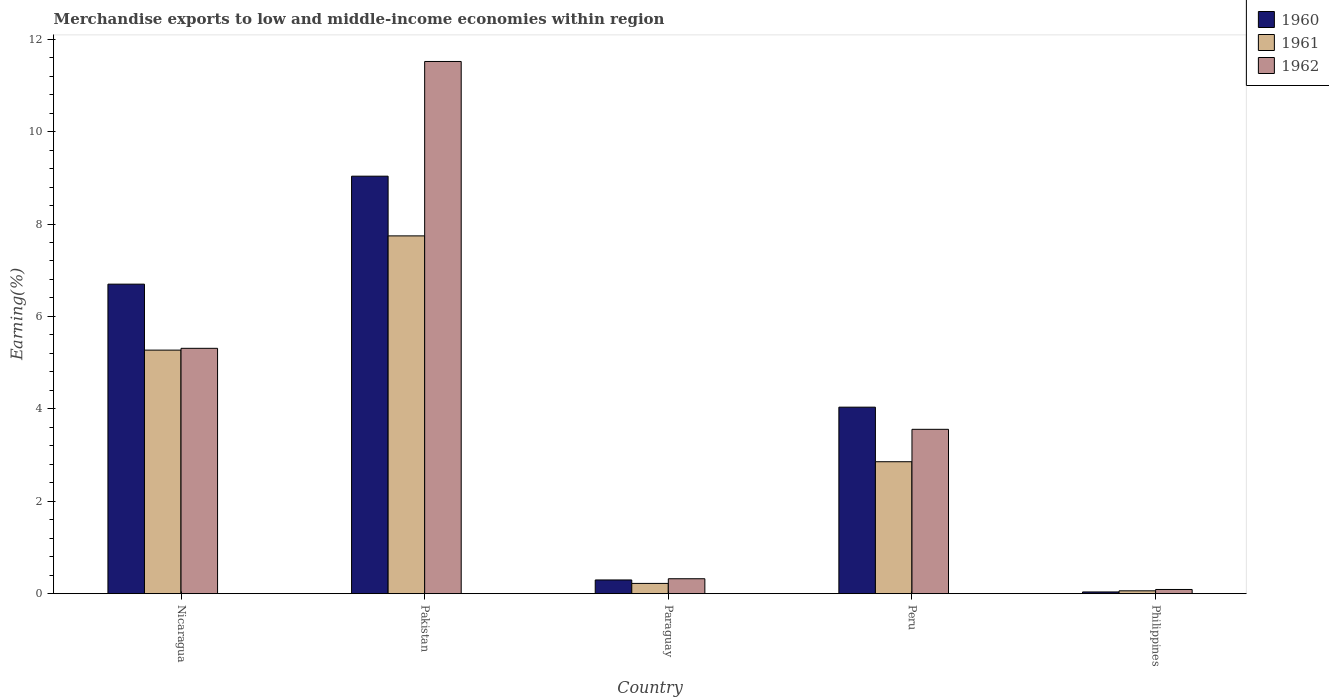Are the number of bars on each tick of the X-axis equal?
Give a very brief answer. Yes. How many bars are there on the 5th tick from the left?
Your answer should be very brief. 3. How many bars are there on the 1st tick from the right?
Ensure brevity in your answer.  3. What is the label of the 1st group of bars from the left?
Give a very brief answer. Nicaragua. What is the percentage of amount earned from merchandise exports in 1962 in Peru?
Give a very brief answer. 3.56. Across all countries, what is the maximum percentage of amount earned from merchandise exports in 1961?
Keep it short and to the point. 7.74. Across all countries, what is the minimum percentage of amount earned from merchandise exports in 1960?
Provide a short and direct response. 0.04. In which country was the percentage of amount earned from merchandise exports in 1961 maximum?
Provide a short and direct response. Pakistan. What is the total percentage of amount earned from merchandise exports in 1962 in the graph?
Provide a short and direct response. 20.8. What is the difference between the percentage of amount earned from merchandise exports in 1960 in Paraguay and that in Peru?
Ensure brevity in your answer.  -3.74. What is the difference between the percentage of amount earned from merchandise exports in 1960 in Pakistan and the percentage of amount earned from merchandise exports in 1962 in Peru?
Make the answer very short. 5.48. What is the average percentage of amount earned from merchandise exports in 1962 per country?
Give a very brief answer. 4.16. What is the difference between the percentage of amount earned from merchandise exports of/in 1962 and percentage of amount earned from merchandise exports of/in 1961 in Peru?
Your answer should be very brief. 0.7. What is the ratio of the percentage of amount earned from merchandise exports in 1962 in Paraguay to that in Peru?
Offer a very short reply. 0.09. What is the difference between the highest and the second highest percentage of amount earned from merchandise exports in 1960?
Offer a terse response. 5. What is the difference between the highest and the lowest percentage of amount earned from merchandise exports in 1961?
Make the answer very short. 7.68. What does the 2nd bar from the right in Philippines represents?
Keep it short and to the point. 1961. Is it the case that in every country, the sum of the percentage of amount earned from merchandise exports in 1962 and percentage of amount earned from merchandise exports in 1961 is greater than the percentage of amount earned from merchandise exports in 1960?
Provide a succinct answer. Yes. What is the difference between two consecutive major ticks on the Y-axis?
Give a very brief answer. 2. Does the graph contain any zero values?
Ensure brevity in your answer.  No. Where does the legend appear in the graph?
Your answer should be very brief. Top right. How are the legend labels stacked?
Offer a terse response. Vertical. What is the title of the graph?
Make the answer very short. Merchandise exports to low and middle-income economies within region. What is the label or title of the Y-axis?
Ensure brevity in your answer.  Earning(%). What is the Earning(%) in 1960 in Nicaragua?
Offer a very short reply. 6.7. What is the Earning(%) in 1961 in Nicaragua?
Provide a short and direct response. 5.27. What is the Earning(%) in 1962 in Nicaragua?
Provide a succinct answer. 5.31. What is the Earning(%) of 1960 in Pakistan?
Give a very brief answer. 9.04. What is the Earning(%) of 1961 in Pakistan?
Ensure brevity in your answer.  7.74. What is the Earning(%) in 1962 in Pakistan?
Ensure brevity in your answer.  11.52. What is the Earning(%) in 1960 in Paraguay?
Keep it short and to the point. 0.3. What is the Earning(%) of 1961 in Paraguay?
Ensure brevity in your answer.  0.22. What is the Earning(%) of 1962 in Paraguay?
Your response must be concise. 0.32. What is the Earning(%) in 1960 in Peru?
Keep it short and to the point. 4.04. What is the Earning(%) in 1961 in Peru?
Provide a succinct answer. 2.86. What is the Earning(%) in 1962 in Peru?
Make the answer very short. 3.56. What is the Earning(%) in 1960 in Philippines?
Your answer should be very brief. 0.04. What is the Earning(%) of 1961 in Philippines?
Give a very brief answer. 0.06. What is the Earning(%) of 1962 in Philippines?
Give a very brief answer. 0.09. Across all countries, what is the maximum Earning(%) in 1960?
Your answer should be very brief. 9.04. Across all countries, what is the maximum Earning(%) in 1961?
Give a very brief answer. 7.74. Across all countries, what is the maximum Earning(%) in 1962?
Offer a terse response. 11.52. Across all countries, what is the minimum Earning(%) of 1960?
Give a very brief answer. 0.04. Across all countries, what is the minimum Earning(%) of 1961?
Give a very brief answer. 0.06. Across all countries, what is the minimum Earning(%) of 1962?
Make the answer very short. 0.09. What is the total Earning(%) of 1960 in the graph?
Offer a very short reply. 20.1. What is the total Earning(%) in 1961 in the graph?
Provide a succinct answer. 16.15. What is the total Earning(%) in 1962 in the graph?
Offer a terse response. 20.8. What is the difference between the Earning(%) in 1960 in Nicaragua and that in Pakistan?
Make the answer very short. -2.34. What is the difference between the Earning(%) in 1961 in Nicaragua and that in Pakistan?
Provide a succinct answer. -2.47. What is the difference between the Earning(%) of 1962 in Nicaragua and that in Pakistan?
Offer a terse response. -6.21. What is the difference between the Earning(%) in 1960 in Nicaragua and that in Paraguay?
Provide a short and direct response. 6.4. What is the difference between the Earning(%) of 1961 in Nicaragua and that in Paraguay?
Ensure brevity in your answer.  5.05. What is the difference between the Earning(%) of 1962 in Nicaragua and that in Paraguay?
Ensure brevity in your answer.  4.99. What is the difference between the Earning(%) of 1960 in Nicaragua and that in Peru?
Give a very brief answer. 2.66. What is the difference between the Earning(%) in 1961 in Nicaragua and that in Peru?
Your answer should be compact. 2.42. What is the difference between the Earning(%) of 1962 in Nicaragua and that in Peru?
Ensure brevity in your answer.  1.75. What is the difference between the Earning(%) of 1960 in Nicaragua and that in Philippines?
Keep it short and to the point. 6.66. What is the difference between the Earning(%) of 1961 in Nicaragua and that in Philippines?
Your answer should be compact. 5.21. What is the difference between the Earning(%) of 1962 in Nicaragua and that in Philippines?
Offer a terse response. 5.22. What is the difference between the Earning(%) of 1960 in Pakistan and that in Paraguay?
Give a very brief answer. 8.74. What is the difference between the Earning(%) of 1961 in Pakistan and that in Paraguay?
Provide a short and direct response. 7.52. What is the difference between the Earning(%) in 1962 in Pakistan and that in Paraguay?
Provide a short and direct response. 11.19. What is the difference between the Earning(%) of 1960 in Pakistan and that in Peru?
Your answer should be very brief. 5. What is the difference between the Earning(%) of 1961 in Pakistan and that in Peru?
Your response must be concise. 4.89. What is the difference between the Earning(%) in 1962 in Pakistan and that in Peru?
Offer a terse response. 7.96. What is the difference between the Earning(%) in 1960 in Pakistan and that in Philippines?
Keep it short and to the point. 9. What is the difference between the Earning(%) of 1961 in Pakistan and that in Philippines?
Offer a terse response. 7.68. What is the difference between the Earning(%) in 1962 in Pakistan and that in Philippines?
Ensure brevity in your answer.  11.43. What is the difference between the Earning(%) of 1960 in Paraguay and that in Peru?
Your answer should be compact. -3.74. What is the difference between the Earning(%) of 1961 in Paraguay and that in Peru?
Your answer should be very brief. -2.63. What is the difference between the Earning(%) in 1962 in Paraguay and that in Peru?
Offer a terse response. -3.23. What is the difference between the Earning(%) of 1960 in Paraguay and that in Philippines?
Give a very brief answer. 0.26. What is the difference between the Earning(%) in 1961 in Paraguay and that in Philippines?
Provide a short and direct response. 0.16. What is the difference between the Earning(%) in 1962 in Paraguay and that in Philippines?
Ensure brevity in your answer.  0.23. What is the difference between the Earning(%) of 1960 in Peru and that in Philippines?
Offer a very short reply. 4. What is the difference between the Earning(%) of 1961 in Peru and that in Philippines?
Your response must be concise. 2.79. What is the difference between the Earning(%) of 1962 in Peru and that in Philippines?
Your answer should be very brief. 3.47. What is the difference between the Earning(%) in 1960 in Nicaragua and the Earning(%) in 1961 in Pakistan?
Ensure brevity in your answer.  -1.04. What is the difference between the Earning(%) in 1960 in Nicaragua and the Earning(%) in 1962 in Pakistan?
Your response must be concise. -4.82. What is the difference between the Earning(%) of 1961 in Nicaragua and the Earning(%) of 1962 in Pakistan?
Offer a very short reply. -6.25. What is the difference between the Earning(%) in 1960 in Nicaragua and the Earning(%) in 1961 in Paraguay?
Make the answer very short. 6.48. What is the difference between the Earning(%) in 1960 in Nicaragua and the Earning(%) in 1962 in Paraguay?
Give a very brief answer. 6.38. What is the difference between the Earning(%) in 1961 in Nicaragua and the Earning(%) in 1962 in Paraguay?
Provide a succinct answer. 4.95. What is the difference between the Earning(%) in 1960 in Nicaragua and the Earning(%) in 1961 in Peru?
Give a very brief answer. 3.84. What is the difference between the Earning(%) in 1960 in Nicaragua and the Earning(%) in 1962 in Peru?
Make the answer very short. 3.14. What is the difference between the Earning(%) of 1961 in Nicaragua and the Earning(%) of 1962 in Peru?
Provide a succinct answer. 1.71. What is the difference between the Earning(%) in 1960 in Nicaragua and the Earning(%) in 1961 in Philippines?
Your response must be concise. 6.64. What is the difference between the Earning(%) in 1960 in Nicaragua and the Earning(%) in 1962 in Philippines?
Provide a short and direct response. 6.61. What is the difference between the Earning(%) of 1961 in Nicaragua and the Earning(%) of 1962 in Philippines?
Ensure brevity in your answer.  5.18. What is the difference between the Earning(%) in 1960 in Pakistan and the Earning(%) in 1961 in Paraguay?
Offer a very short reply. 8.81. What is the difference between the Earning(%) in 1960 in Pakistan and the Earning(%) in 1962 in Paraguay?
Offer a terse response. 8.71. What is the difference between the Earning(%) in 1961 in Pakistan and the Earning(%) in 1962 in Paraguay?
Your answer should be very brief. 7.42. What is the difference between the Earning(%) of 1960 in Pakistan and the Earning(%) of 1961 in Peru?
Your answer should be very brief. 6.18. What is the difference between the Earning(%) of 1960 in Pakistan and the Earning(%) of 1962 in Peru?
Provide a succinct answer. 5.48. What is the difference between the Earning(%) of 1961 in Pakistan and the Earning(%) of 1962 in Peru?
Keep it short and to the point. 4.19. What is the difference between the Earning(%) of 1960 in Pakistan and the Earning(%) of 1961 in Philippines?
Provide a succinct answer. 8.97. What is the difference between the Earning(%) of 1960 in Pakistan and the Earning(%) of 1962 in Philippines?
Make the answer very short. 8.94. What is the difference between the Earning(%) in 1961 in Pakistan and the Earning(%) in 1962 in Philippines?
Your answer should be very brief. 7.65. What is the difference between the Earning(%) of 1960 in Paraguay and the Earning(%) of 1961 in Peru?
Your response must be concise. -2.56. What is the difference between the Earning(%) of 1960 in Paraguay and the Earning(%) of 1962 in Peru?
Provide a short and direct response. -3.26. What is the difference between the Earning(%) in 1961 in Paraguay and the Earning(%) in 1962 in Peru?
Your answer should be compact. -3.33. What is the difference between the Earning(%) in 1960 in Paraguay and the Earning(%) in 1961 in Philippines?
Provide a short and direct response. 0.23. What is the difference between the Earning(%) of 1960 in Paraguay and the Earning(%) of 1962 in Philippines?
Your answer should be very brief. 0.21. What is the difference between the Earning(%) in 1961 in Paraguay and the Earning(%) in 1962 in Philippines?
Keep it short and to the point. 0.13. What is the difference between the Earning(%) of 1960 in Peru and the Earning(%) of 1961 in Philippines?
Your response must be concise. 3.97. What is the difference between the Earning(%) of 1960 in Peru and the Earning(%) of 1962 in Philippines?
Offer a terse response. 3.95. What is the difference between the Earning(%) of 1961 in Peru and the Earning(%) of 1962 in Philippines?
Give a very brief answer. 2.77. What is the average Earning(%) of 1960 per country?
Offer a very short reply. 4.02. What is the average Earning(%) in 1961 per country?
Ensure brevity in your answer.  3.23. What is the average Earning(%) in 1962 per country?
Your answer should be very brief. 4.16. What is the difference between the Earning(%) of 1960 and Earning(%) of 1961 in Nicaragua?
Give a very brief answer. 1.43. What is the difference between the Earning(%) of 1960 and Earning(%) of 1962 in Nicaragua?
Offer a very short reply. 1.39. What is the difference between the Earning(%) in 1961 and Earning(%) in 1962 in Nicaragua?
Offer a very short reply. -0.04. What is the difference between the Earning(%) of 1960 and Earning(%) of 1961 in Pakistan?
Give a very brief answer. 1.29. What is the difference between the Earning(%) of 1960 and Earning(%) of 1962 in Pakistan?
Offer a terse response. -2.48. What is the difference between the Earning(%) in 1961 and Earning(%) in 1962 in Pakistan?
Your answer should be very brief. -3.77. What is the difference between the Earning(%) in 1960 and Earning(%) in 1961 in Paraguay?
Keep it short and to the point. 0.07. What is the difference between the Earning(%) of 1960 and Earning(%) of 1962 in Paraguay?
Offer a very short reply. -0.03. What is the difference between the Earning(%) in 1961 and Earning(%) in 1962 in Paraguay?
Give a very brief answer. -0.1. What is the difference between the Earning(%) of 1960 and Earning(%) of 1961 in Peru?
Your answer should be compact. 1.18. What is the difference between the Earning(%) of 1960 and Earning(%) of 1962 in Peru?
Provide a short and direct response. 0.48. What is the difference between the Earning(%) in 1961 and Earning(%) in 1962 in Peru?
Provide a short and direct response. -0.7. What is the difference between the Earning(%) in 1960 and Earning(%) in 1961 in Philippines?
Offer a very short reply. -0.02. What is the difference between the Earning(%) of 1960 and Earning(%) of 1962 in Philippines?
Make the answer very short. -0.05. What is the difference between the Earning(%) in 1961 and Earning(%) in 1962 in Philippines?
Your answer should be compact. -0.03. What is the ratio of the Earning(%) of 1960 in Nicaragua to that in Pakistan?
Your answer should be very brief. 0.74. What is the ratio of the Earning(%) in 1961 in Nicaragua to that in Pakistan?
Your answer should be compact. 0.68. What is the ratio of the Earning(%) in 1962 in Nicaragua to that in Pakistan?
Your response must be concise. 0.46. What is the ratio of the Earning(%) of 1960 in Nicaragua to that in Paraguay?
Your response must be concise. 22.59. What is the ratio of the Earning(%) of 1961 in Nicaragua to that in Paraguay?
Offer a terse response. 23.78. What is the ratio of the Earning(%) in 1962 in Nicaragua to that in Paraguay?
Offer a terse response. 16.45. What is the ratio of the Earning(%) in 1960 in Nicaragua to that in Peru?
Your answer should be very brief. 1.66. What is the ratio of the Earning(%) of 1961 in Nicaragua to that in Peru?
Ensure brevity in your answer.  1.85. What is the ratio of the Earning(%) in 1962 in Nicaragua to that in Peru?
Ensure brevity in your answer.  1.49. What is the ratio of the Earning(%) in 1960 in Nicaragua to that in Philippines?
Offer a very short reply. 179.86. What is the ratio of the Earning(%) of 1961 in Nicaragua to that in Philippines?
Offer a terse response. 85.65. What is the ratio of the Earning(%) of 1962 in Nicaragua to that in Philippines?
Your response must be concise. 58.75. What is the ratio of the Earning(%) of 1960 in Pakistan to that in Paraguay?
Your answer should be very brief. 30.47. What is the ratio of the Earning(%) of 1961 in Pakistan to that in Paraguay?
Give a very brief answer. 34.93. What is the ratio of the Earning(%) of 1962 in Pakistan to that in Paraguay?
Make the answer very short. 35.69. What is the ratio of the Earning(%) of 1960 in Pakistan to that in Peru?
Your answer should be very brief. 2.24. What is the ratio of the Earning(%) in 1961 in Pakistan to that in Peru?
Make the answer very short. 2.71. What is the ratio of the Earning(%) in 1962 in Pakistan to that in Peru?
Your answer should be very brief. 3.24. What is the ratio of the Earning(%) in 1960 in Pakistan to that in Philippines?
Provide a short and direct response. 242.6. What is the ratio of the Earning(%) in 1961 in Pakistan to that in Philippines?
Your response must be concise. 125.83. What is the ratio of the Earning(%) of 1962 in Pakistan to that in Philippines?
Ensure brevity in your answer.  127.43. What is the ratio of the Earning(%) of 1960 in Paraguay to that in Peru?
Give a very brief answer. 0.07. What is the ratio of the Earning(%) in 1961 in Paraguay to that in Peru?
Provide a succinct answer. 0.08. What is the ratio of the Earning(%) in 1962 in Paraguay to that in Peru?
Ensure brevity in your answer.  0.09. What is the ratio of the Earning(%) of 1960 in Paraguay to that in Philippines?
Ensure brevity in your answer.  7.96. What is the ratio of the Earning(%) in 1961 in Paraguay to that in Philippines?
Ensure brevity in your answer.  3.6. What is the ratio of the Earning(%) in 1962 in Paraguay to that in Philippines?
Make the answer very short. 3.57. What is the ratio of the Earning(%) in 1960 in Peru to that in Philippines?
Provide a short and direct response. 108.37. What is the ratio of the Earning(%) of 1961 in Peru to that in Philippines?
Your answer should be compact. 46.4. What is the ratio of the Earning(%) in 1962 in Peru to that in Philippines?
Offer a very short reply. 39.35. What is the difference between the highest and the second highest Earning(%) of 1960?
Offer a terse response. 2.34. What is the difference between the highest and the second highest Earning(%) in 1961?
Your response must be concise. 2.47. What is the difference between the highest and the second highest Earning(%) of 1962?
Make the answer very short. 6.21. What is the difference between the highest and the lowest Earning(%) of 1960?
Offer a very short reply. 9. What is the difference between the highest and the lowest Earning(%) of 1961?
Ensure brevity in your answer.  7.68. What is the difference between the highest and the lowest Earning(%) in 1962?
Offer a very short reply. 11.43. 